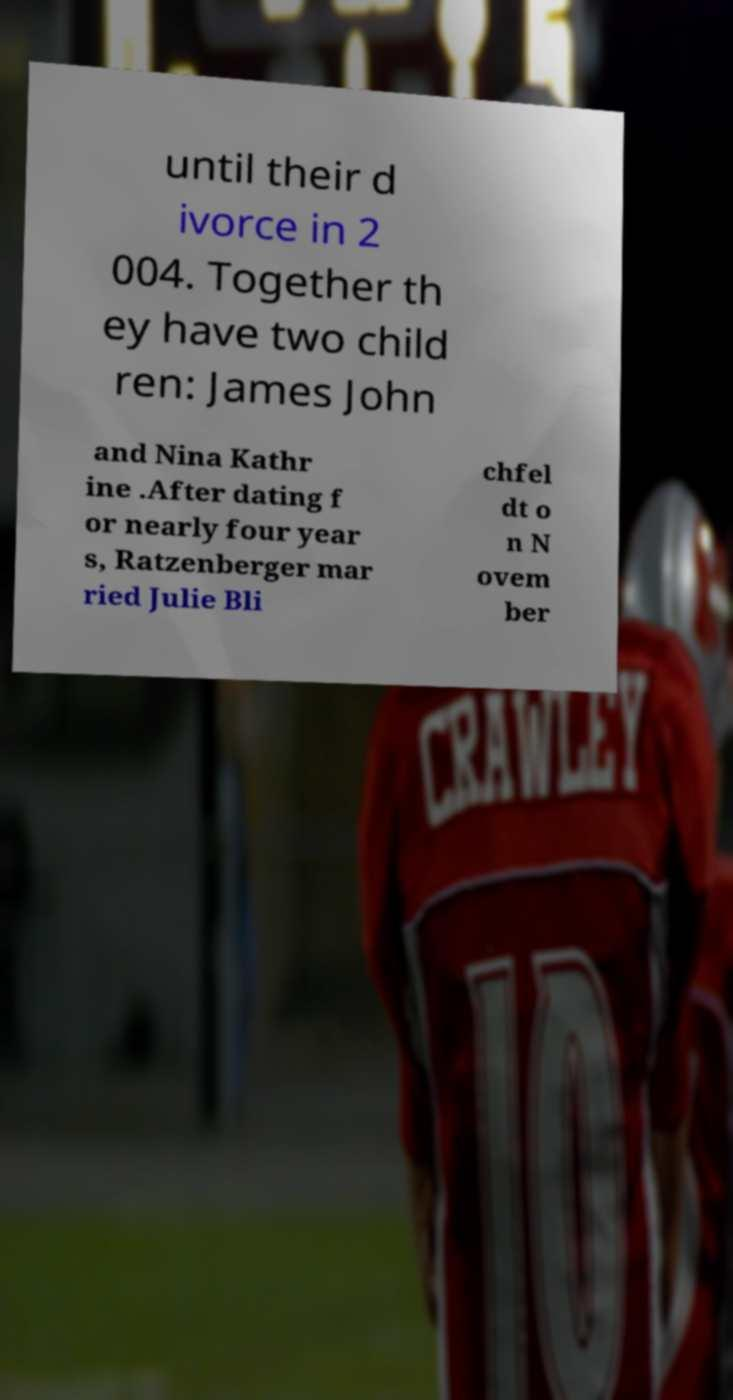Can you accurately transcribe the text from the provided image for me? until their d ivorce in 2 004. Together th ey have two child ren: James John and Nina Kathr ine .After dating f or nearly four year s, Ratzenberger mar ried Julie Bli chfel dt o n N ovem ber 